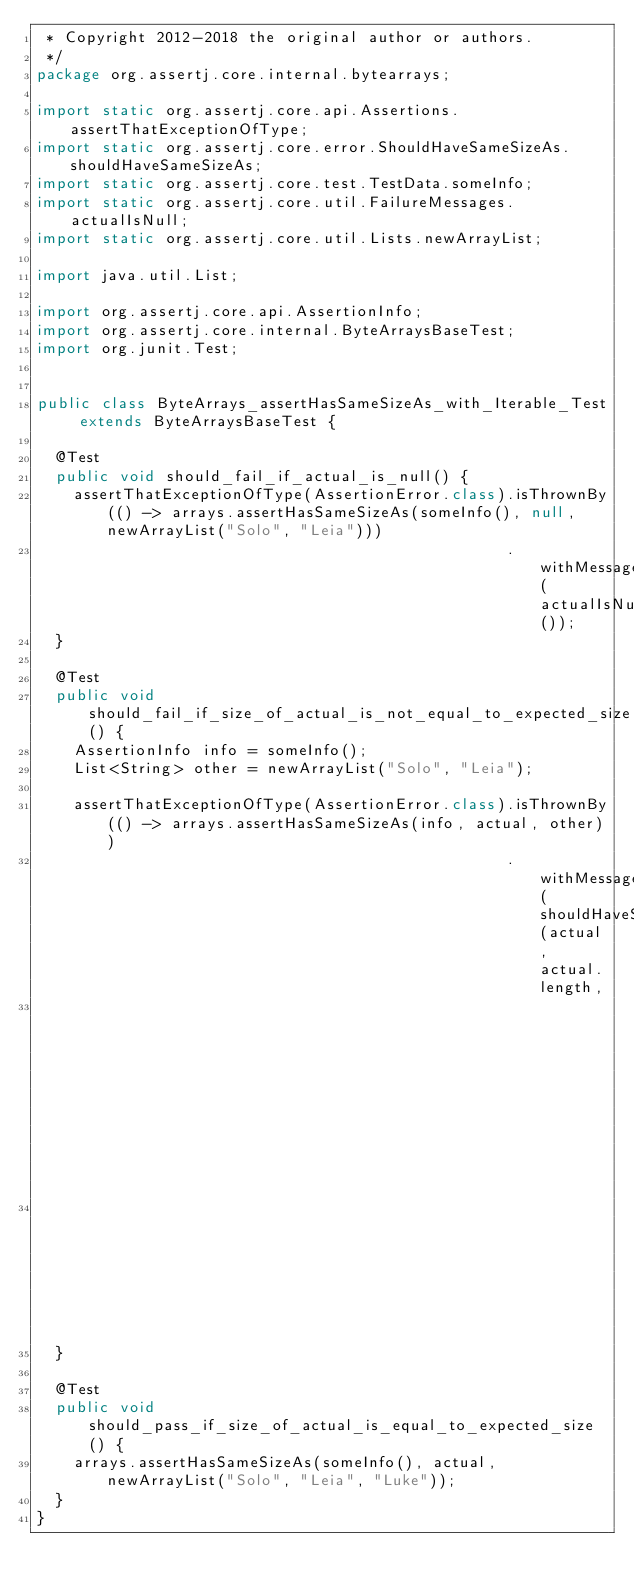<code> <loc_0><loc_0><loc_500><loc_500><_Java_> * Copyright 2012-2018 the original author or authors.
 */
package org.assertj.core.internal.bytearrays;

import static org.assertj.core.api.Assertions.assertThatExceptionOfType;
import static org.assertj.core.error.ShouldHaveSameSizeAs.shouldHaveSameSizeAs;
import static org.assertj.core.test.TestData.someInfo;
import static org.assertj.core.util.FailureMessages.actualIsNull;
import static org.assertj.core.util.Lists.newArrayList;

import java.util.List;

import org.assertj.core.api.AssertionInfo;
import org.assertj.core.internal.ByteArraysBaseTest;
import org.junit.Test;


public class ByteArrays_assertHasSameSizeAs_with_Iterable_Test extends ByteArraysBaseTest {

  @Test
  public void should_fail_if_actual_is_null() {
    assertThatExceptionOfType(AssertionError.class).isThrownBy(() -> arrays.assertHasSameSizeAs(someInfo(), null, newArrayList("Solo", "Leia")))
                                                   .withMessage(actualIsNull());
  }

  @Test
  public void should_fail_if_size_of_actual_is_not_equal_to_expected_size() {
    AssertionInfo info = someInfo();
    List<String> other = newArrayList("Solo", "Leia");

    assertThatExceptionOfType(AssertionError.class).isThrownBy(() -> arrays.assertHasSameSizeAs(info, actual, other))
                                                   .withMessage(shouldHaveSameSizeAs(actual, actual.length,
                                                                                     other.size()).create(null,
                                                                                                          info.representation()));
  }

  @Test
  public void should_pass_if_size_of_actual_is_equal_to_expected_size() {
    arrays.assertHasSameSizeAs(someInfo(), actual, newArrayList("Solo", "Leia", "Luke"));
  }
}
</code> 